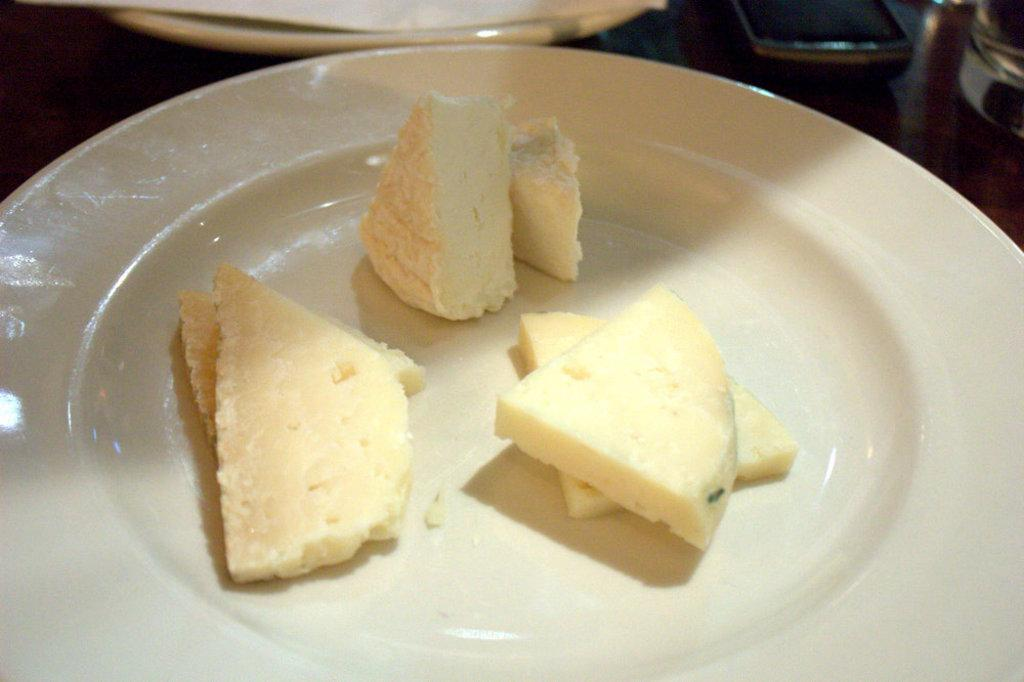What is on the plate that is visible in the image? There is food in a plate in the image. Can you describe the other plate in the image? There is another plate in the background of the image. What electronic device is on the table in the image? There is a mobile phone on the table in the image. What type of drink is in the glass on the table in the image? There is a glass of water on the table in the image. How does the dirt affect the food on the plate in the image? There is no dirt present in the image, so it does not affect the food on the plate. 